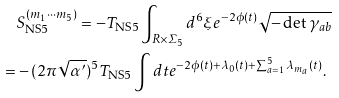<formula> <loc_0><loc_0><loc_500><loc_500>& S ^ { ( m _ { 1 } \cdots m _ { 5 } ) } _ { \text {NS} 5 } = - T _ { \text {NS} 5 } \int _ { R \times \varSigma _ { 5 } } d ^ { 6 } \xi e ^ { - 2 \phi ( t ) } \sqrt { - \det \gamma _ { a b } } \\ = & - ( 2 \pi \sqrt { \alpha ^ { \prime } } ) ^ { 5 } T _ { \text {NS} 5 } \int d t e ^ { - 2 \phi ( t ) + \lambda _ { 0 } ( t ) + \sum _ { a = 1 } ^ { 5 } \lambda _ { m _ { a } } ( t ) } .</formula> 